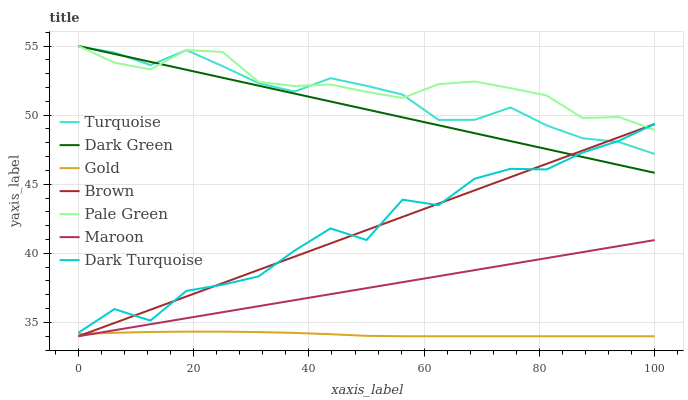Does Gold have the minimum area under the curve?
Answer yes or no. Yes. Does Pale Green have the maximum area under the curve?
Answer yes or no. Yes. Does Turquoise have the minimum area under the curve?
Answer yes or no. No. Does Turquoise have the maximum area under the curve?
Answer yes or no. No. Is Maroon the smoothest?
Answer yes or no. Yes. Is Dark Turquoise the roughest?
Answer yes or no. Yes. Is Turquoise the smoothest?
Answer yes or no. No. Is Turquoise the roughest?
Answer yes or no. No. Does Brown have the lowest value?
Answer yes or no. Yes. Does Turquoise have the lowest value?
Answer yes or no. No. Does Dark Green have the highest value?
Answer yes or no. Yes. Does Turquoise have the highest value?
Answer yes or no. No. Is Maroon less than Dark Green?
Answer yes or no. Yes. Is Dark Turquoise greater than Gold?
Answer yes or no. Yes. Does Dark Green intersect Pale Green?
Answer yes or no. Yes. Is Dark Green less than Pale Green?
Answer yes or no. No. Is Dark Green greater than Pale Green?
Answer yes or no. No. Does Maroon intersect Dark Green?
Answer yes or no. No. 